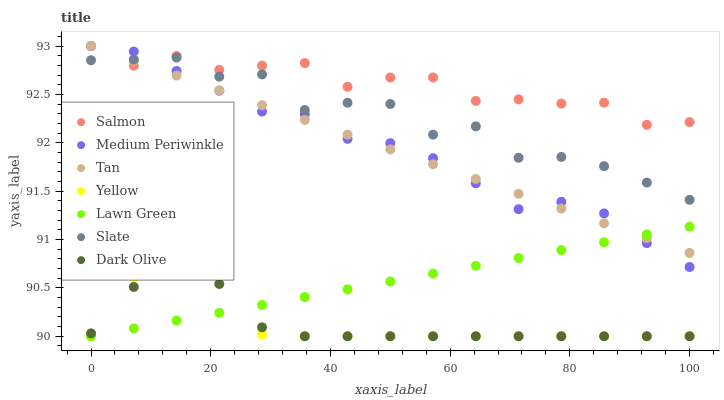Does Dark Olive have the minimum area under the curve?
Answer yes or no. Yes. Does Salmon have the maximum area under the curve?
Answer yes or no. Yes. Does Slate have the minimum area under the curve?
Answer yes or no. No. Does Slate have the maximum area under the curve?
Answer yes or no. No. Is Lawn Green the smoothest?
Answer yes or no. Yes. Is Slate the roughest?
Answer yes or no. Yes. Is Salmon the smoothest?
Answer yes or no. No. Is Salmon the roughest?
Answer yes or no. No. Does Lawn Green have the lowest value?
Answer yes or no. Yes. Does Slate have the lowest value?
Answer yes or no. No. Does Tan have the highest value?
Answer yes or no. Yes. Does Slate have the highest value?
Answer yes or no. No. Is Dark Olive less than Salmon?
Answer yes or no. Yes. Is Medium Periwinkle greater than Dark Olive?
Answer yes or no. Yes. Does Yellow intersect Lawn Green?
Answer yes or no. Yes. Is Yellow less than Lawn Green?
Answer yes or no. No. Is Yellow greater than Lawn Green?
Answer yes or no. No. Does Dark Olive intersect Salmon?
Answer yes or no. No. 